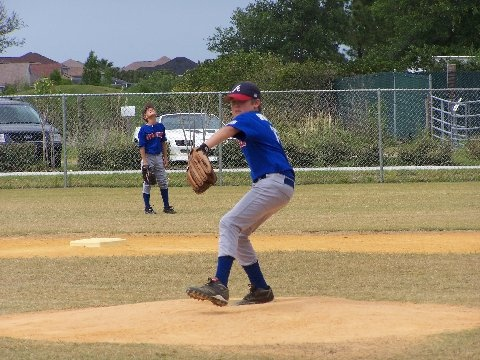Describe the objects in this image and their specific colors. I can see people in darkgray, navy, gray, and black tones, car in darkgray, gray, and black tones, car in darkgray, white, and gray tones, people in darkgray, black, gray, and navy tones, and baseball glove in darkgray, gray, maroon, tan, and black tones in this image. 